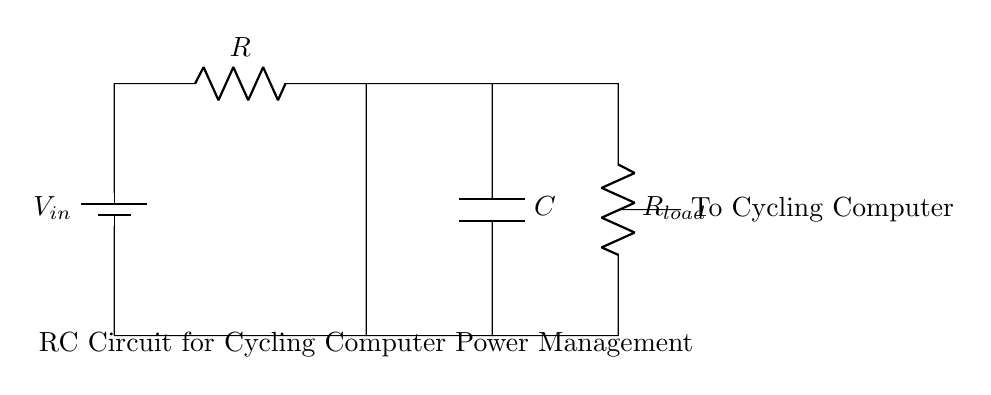What does the battery represent? The battery in the circuit diagram represents a voltage source providing power to the RC circuit. It is the component responsible for establishing the potential difference necessary for current flow.
Answer: Voltage source What type of capacitor is used in the circuit? The circuit diagram does not specify the type of capacitor; it simply illustrates a capacitor as part of the RC circuit. The type could be electrolytic, ceramic, etc., but this information is not provided here.
Answer: Not specified What is the function of the resistor labeled R? The resistor R limits the current flowing through the circuit, which can be important for the stability and operation of the cycling computer it powers. It affects the time constant of the RC charging and discharging cycles.
Answer: Current limiting How does the RC time constant relate to this circuit? The RC time constant, calculated as the product of the resistance R and the capacitance C, determines the charging and discharging rate of the capacitor in the circuit. This affects how quickly the cycling computer can respond to changes in power supply conditions.
Answer: Charging rate What happens to the voltage across the capacitor during charging? During charging, the voltage across the capacitor increases exponentially until it approaches the input voltage V in, regulated by the resistor R. This is due to the nature of capacitor charging in an RC circuit, where the voltage rises over time following a specific time constant.
Answer: Increases exponentially What will occur if the load resistance R load is decreased? If the load resistance R load is decreased, more current will be drawn from the capacitor when discharging, which can lead to a rapid drop in the voltage across the cycling computer, potentially affecting its performance.
Answer: Voltage drop 